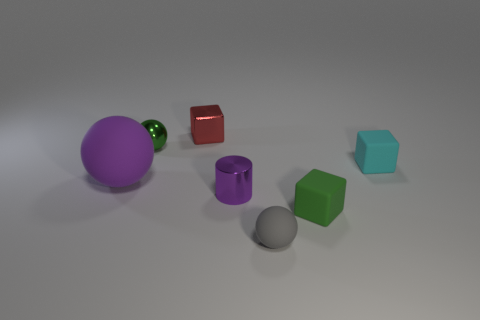Are there any tiny yellow spheres made of the same material as the red block?
Keep it short and to the point. No. There is a red block that is the same size as the cyan cube; what is its material?
Make the answer very short. Metal. There is a matte block that is behind the big ball; is its color the same as the small sphere behind the tiny gray object?
Your answer should be very brief. No. Are there any small metallic things that are behind the green thing that is behind the big purple matte thing?
Give a very brief answer. Yes. Does the metal thing that is right of the small shiny block have the same shape as the green thing that is in front of the purple sphere?
Your response must be concise. No. Is the tiny ball on the left side of the gray object made of the same material as the purple thing that is to the right of the tiny red cube?
Ensure brevity in your answer.  Yes. There is a small green thing on the left side of the rubber ball on the right side of the tiny green shiny ball; what is its material?
Ensure brevity in your answer.  Metal. What is the shape of the object behind the green thing that is left of the green matte object behind the small gray thing?
Provide a short and direct response. Cube. There is a green object that is the same shape as the red thing; what is it made of?
Provide a short and direct response. Rubber. How many cyan objects are there?
Ensure brevity in your answer.  1. 